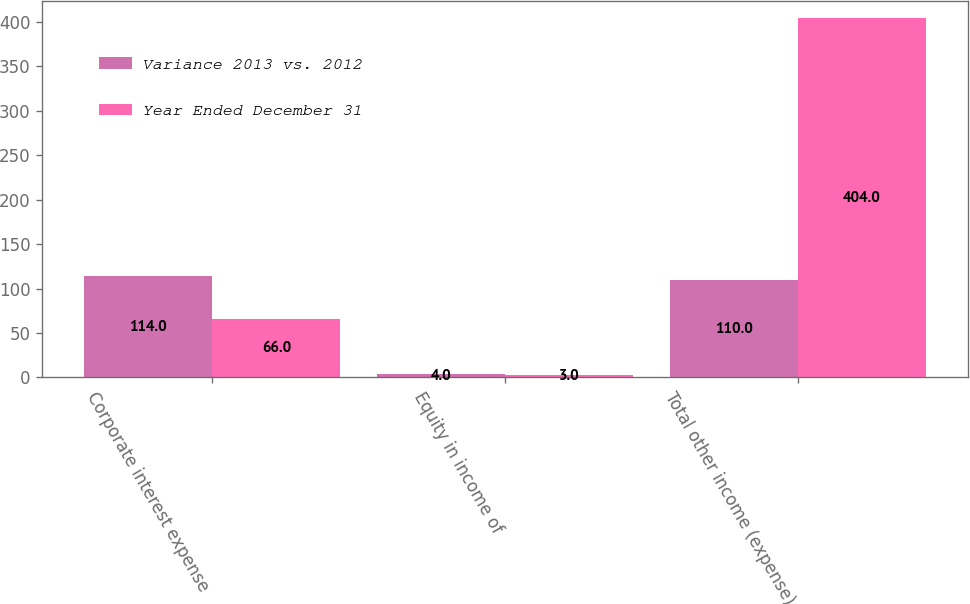Convert chart to OTSL. <chart><loc_0><loc_0><loc_500><loc_500><stacked_bar_chart><ecel><fcel>Corporate interest expense<fcel>Equity in income of<fcel>Total other income (expense)<nl><fcel>Variance 2013 vs. 2012<fcel>114<fcel>4<fcel>110<nl><fcel>Year Ended December 31<fcel>66<fcel>3<fcel>404<nl></chart> 